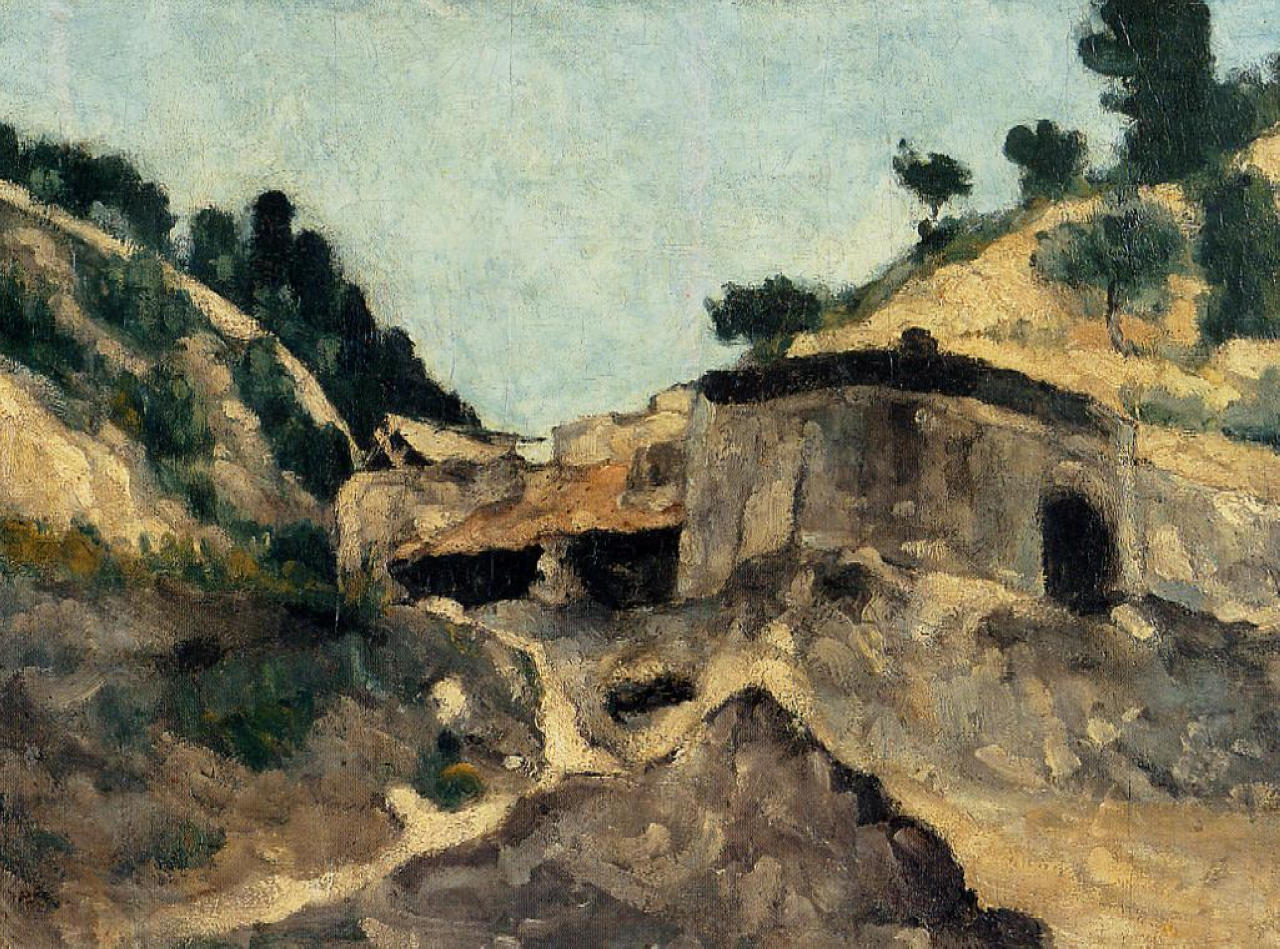How does the artist use color to enhance the scene? The artist masterfully uses earthy hues to highlight the aged and weathered stone building, creating a strong sense of historical depth. The surrounding landscape, painted in various shades of green and brown, complements the building and adds texture, conveying the rustic beauty of nature. The use of loose, impressionistic brushstrokes in the greenery introduces a dynamic, lively quality. In contrast, the sky is rendered in calming blues, injecting tranquility and balancing the rugged, vibrant foreground. This contrast between the earthy tones and the soothing blues amplifies the emotional resonance and visual depth of the artwork. Can you paint a vivid narrative involving the landscape and the building? In a bygone era, this stone building served as a sanctuary for weary travelers journeying through the hilly terrain. Nestled amid the rolling landscape, it stood as a beacon of rest. As dusk fell, the travelers would gather inside, sharing tales of adventures under the dim glow of lantern light. The landscape outside, tranquil and expansive, provided a perfect backdrop to their stories. The trees whispered secrets of the ages as the wind rustled their leaves. Seasons changed, and the lush greenery bloomed vibrantly in spring, while autumn painted the hills in warm, earthy tones. As years turned into decades, the building stood resolute, with its stones silently bearing witness to a tapestry of countless human stories interwoven with the natural beauty around it. 